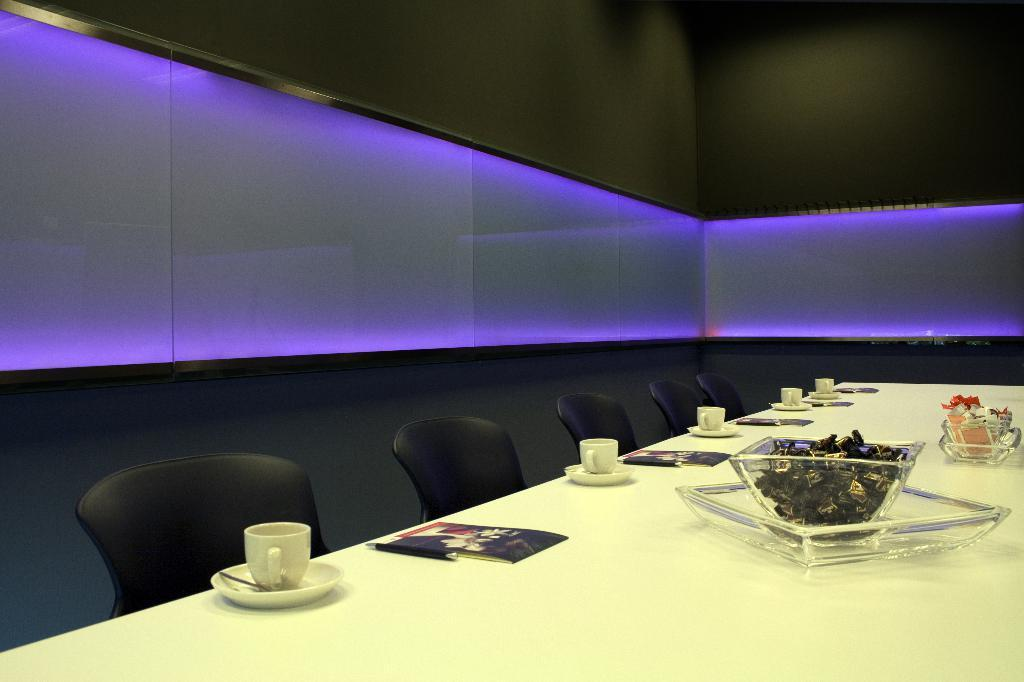What type of furniture is present in the image? There is a chair and a table in the image. What is on the table in the image? There is a bowl of chocolates, a cup and saucer, a notepad, and a pen on the table. What is the purpose of the notepad and pen? The notepad and pen might be used for writing or taking notes. What can be seen in the background of the image? There is a wall in the background of the image. Can you tell me how many cracks are visible on the wall in the image? There is no information about any cracks on the wall in the image. What type of kitten can be seen playing in the alley behind the wall in the image? There is no alley or kitten present in the image. 